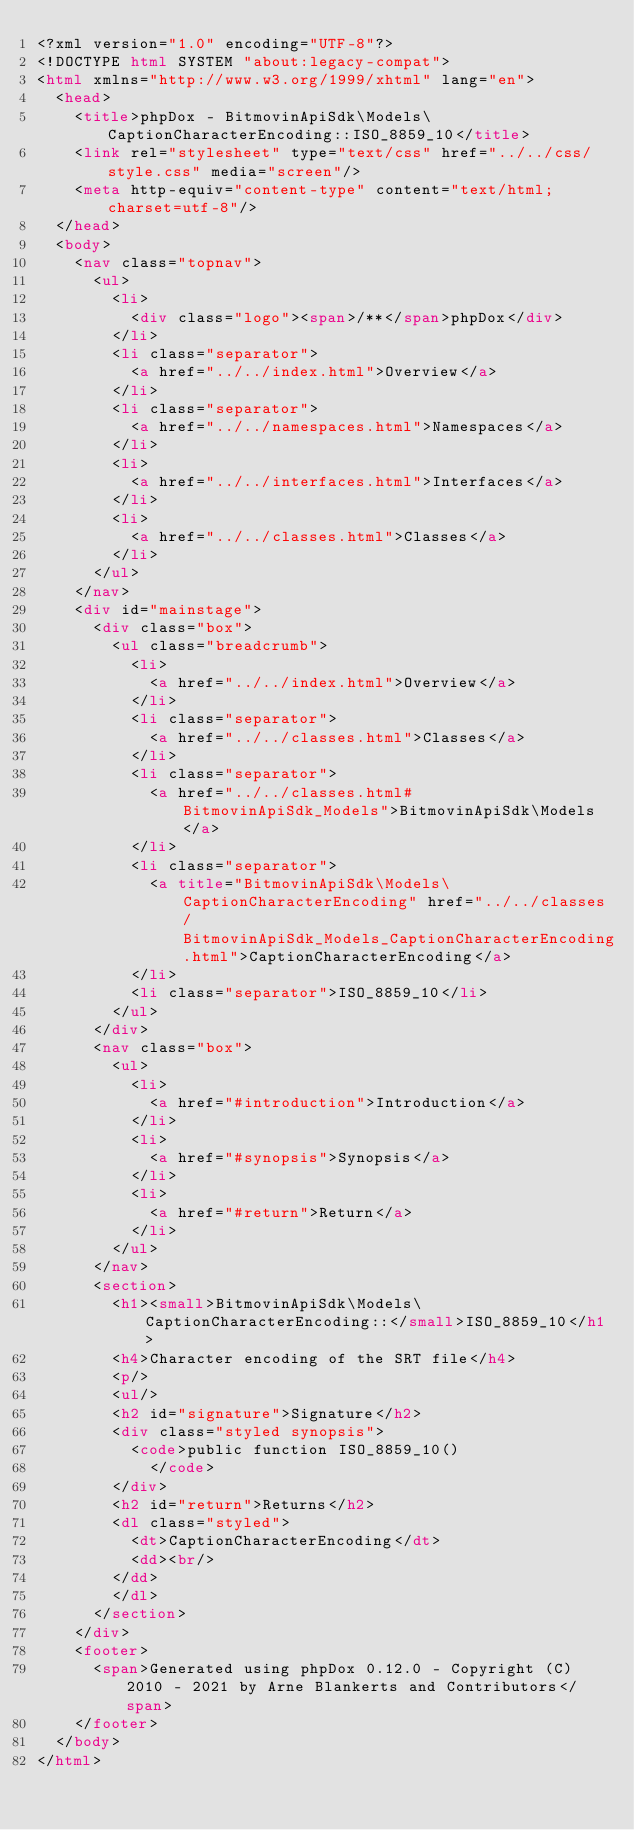Convert code to text. <code><loc_0><loc_0><loc_500><loc_500><_HTML_><?xml version="1.0" encoding="UTF-8"?>
<!DOCTYPE html SYSTEM "about:legacy-compat">
<html xmlns="http://www.w3.org/1999/xhtml" lang="en">
  <head>
    <title>phpDox - BitmovinApiSdk\Models\CaptionCharacterEncoding::ISO_8859_10</title>
    <link rel="stylesheet" type="text/css" href="../../css/style.css" media="screen"/>
    <meta http-equiv="content-type" content="text/html; charset=utf-8"/>
  </head>
  <body>
    <nav class="topnav">
      <ul>
        <li>
          <div class="logo"><span>/**</span>phpDox</div>
        </li>
        <li class="separator">
          <a href="../../index.html">Overview</a>
        </li>
        <li class="separator">
          <a href="../../namespaces.html">Namespaces</a>
        </li>
        <li>
          <a href="../../interfaces.html">Interfaces</a>
        </li>
        <li>
          <a href="../../classes.html">Classes</a>
        </li>
      </ul>
    </nav>
    <div id="mainstage">
      <div class="box">
        <ul class="breadcrumb">
          <li>
            <a href="../../index.html">Overview</a>
          </li>
          <li class="separator">
            <a href="../../classes.html">Classes</a>
          </li>
          <li class="separator">
            <a href="../../classes.html#BitmovinApiSdk_Models">BitmovinApiSdk\Models</a>
          </li>
          <li class="separator">
            <a title="BitmovinApiSdk\Models\CaptionCharacterEncoding" href="../../classes/BitmovinApiSdk_Models_CaptionCharacterEncoding.html">CaptionCharacterEncoding</a>
          </li>
          <li class="separator">ISO_8859_10</li>
        </ul>
      </div>
      <nav class="box">
        <ul>
          <li>
            <a href="#introduction">Introduction</a>
          </li>
          <li>
            <a href="#synopsis">Synopsis</a>
          </li>
          <li>
            <a href="#return">Return</a>
          </li>
        </ul>
      </nav>
      <section>
        <h1><small>BitmovinApiSdk\Models\CaptionCharacterEncoding::</small>ISO_8859_10</h1>
        <h4>Character encoding of the SRT file</h4>
        <p/>
        <ul/>
        <h2 id="signature">Signature</h2>
        <div class="styled synopsis">
          <code>public function ISO_8859_10()
            </code>
        </div>
        <h2 id="return">Returns</h2>
        <dl class="styled">
          <dt>CaptionCharacterEncoding</dt>
          <dd><br/>
        </dd>
        </dl>
      </section>
    </div>
    <footer>
      <span>Generated using phpDox 0.12.0 - Copyright (C) 2010 - 2021 by Arne Blankerts and Contributors</span>
    </footer>
  </body>
</html>
</code> 